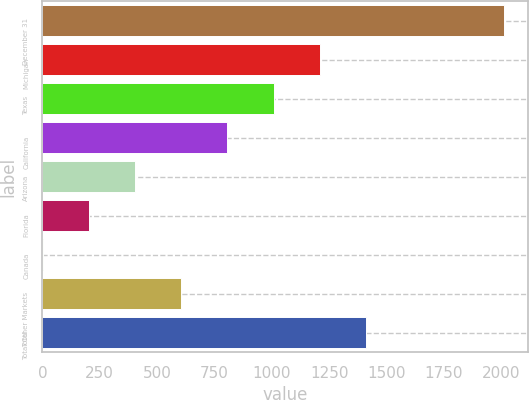<chart> <loc_0><loc_0><loc_500><loc_500><bar_chart><fcel>December 31<fcel>Michigan<fcel>Texas<fcel>California<fcel>Arizona<fcel>Florida<fcel>Canada<fcel>Total Other Markets<fcel>Total<nl><fcel>2014<fcel>1208.8<fcel>1007.5<fcel>806.2<fcel>403.6<fcel>202.3<fcel>1<fcel>604.9<fcel>1410.1<nl></chart> 